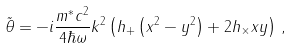<formula> <loc_0><loc_0><loc_500><loc_500>\tilde { \theta } = - i \frac { m ^ { \ast } c ^ { 2 } } { 4 \hbar { \omega } } k ^ { 2 } \left ( h _ { + } \left ( x ^ { 2 } - y ^ { 2 } \right ) + 2 h _ { \times } x y \right ) \, ,</formula> 